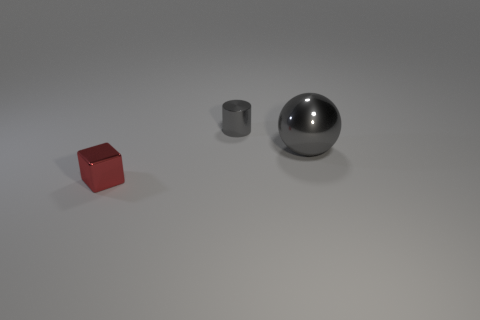Add 3 brown cylinders. How many objects exist? 6 Subtract all cylinders. How many objects are left? 2 Subtract 0 blue cylinders. How many objects are left? 3 Subtract all large purple rubber balls. Subtract all shiny objects. How many objects are left? 0 Add 1 red objects. How many red objects are left? 2 Add 2 big gray things. How many big gray things exist? 3 